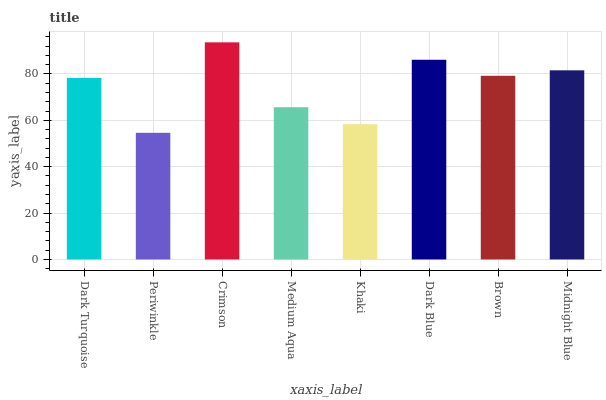Is Crimson the minimum?
Answer yes or no. No. Is Periwinkle the maximum?
Answer yes or no. No. Is Crimson greater than Periwinkle?
Answer yes or no. Yes. Is Periwinkle less than Crimson?
Answer yes or no. Yes. Is Periwinkle greater than Crimson?
Answer yes or no. No. Is Crimson less than Periwinkle?
Answer yes or no. No. Is Brown the high median?
Answer yes or no. Yes. Is Dark Turquoise the low median?
Answer yes or no. Yes. Is Crimson the high median?
Answer yes or no. No. Is Brown the low median?
Answer yes or no. No. 